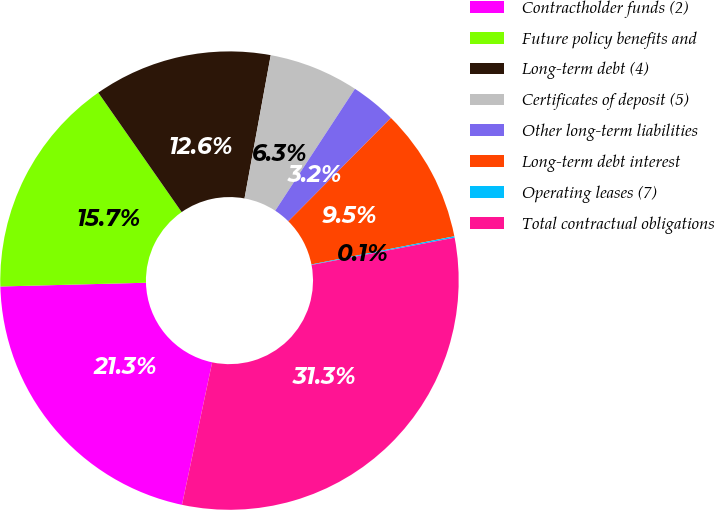<chart> <loc_0><loc_0><loc_500><loc_500><pie_chart><fcel>Contractholder funds (2)<fcel>Future policy benefits and<fcel>Long-term debt (4)<fcel>Certificates of deposit (5)<fcel>Other long-term liabilities<fcel>Long-term debt interest<fcel>Operating leases (7)<fcel>Total contractual obligations<nl><fcel>21.27%<fcel>15.71%<fcel>12.58%<fcel>6.34%<fcel>3.22%<fcel>9.46%<fcel>0.1%<fcel>31.32%<nl></chart> 